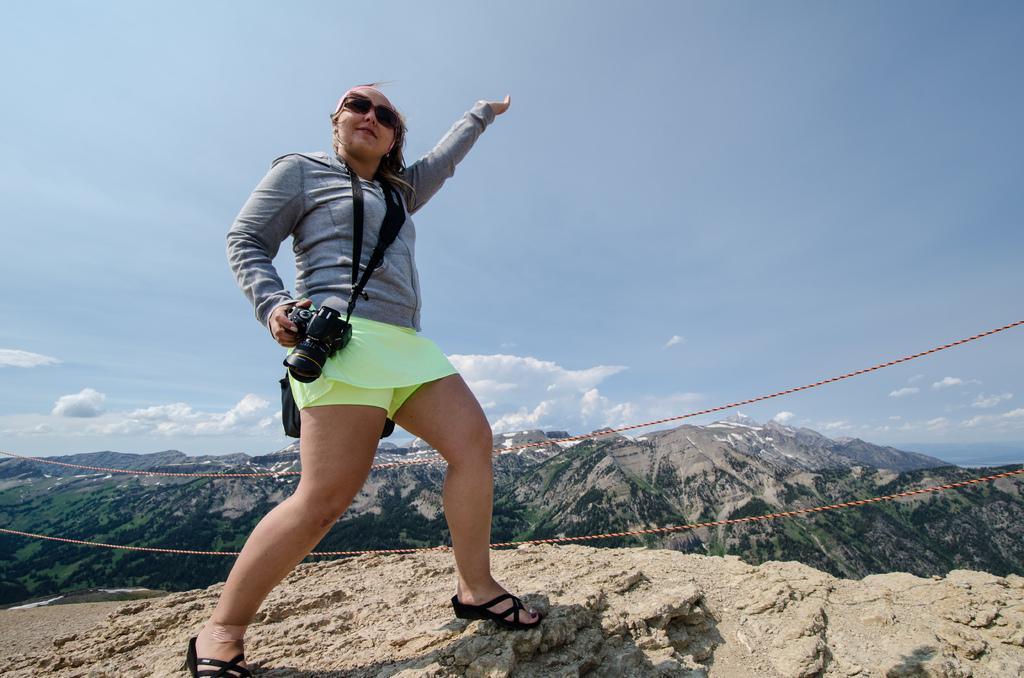How would you summarize this image in a sentence or two? There is a woman in this picture standing on the hill, holding a camera, wearing a spectacles. In the background, there are some ropes, hills and a sky with some clouds. 